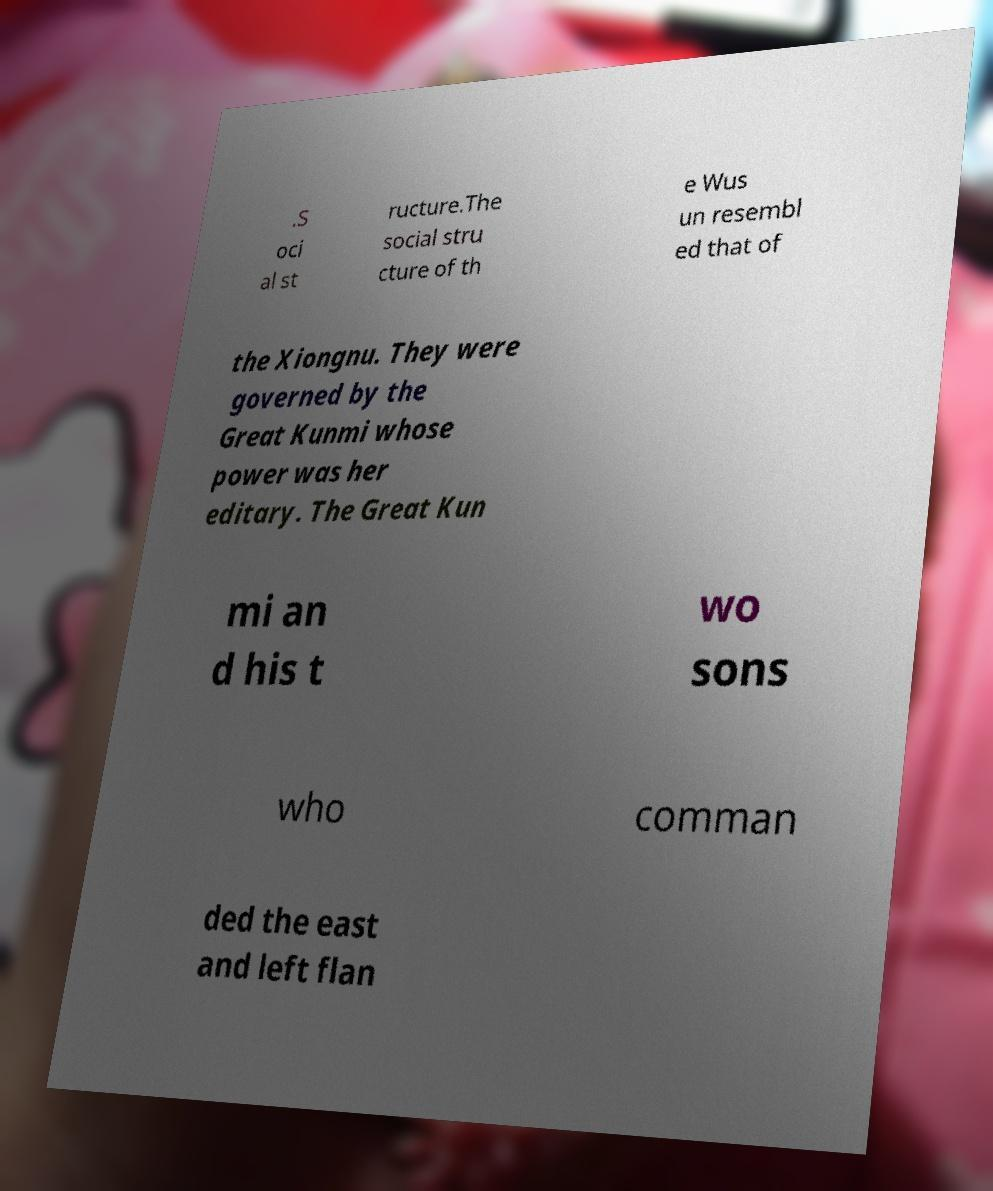I need the written content from this picture converted into text. Can you do that? .S oci al st ructure.The social stru cture of th e Wus un resembl ed that of the Xiongnu. They were governed by the Great Kunmi whose power was her editary. The Great Kun mi an d his t wo sons who comman ded the east and left flan 